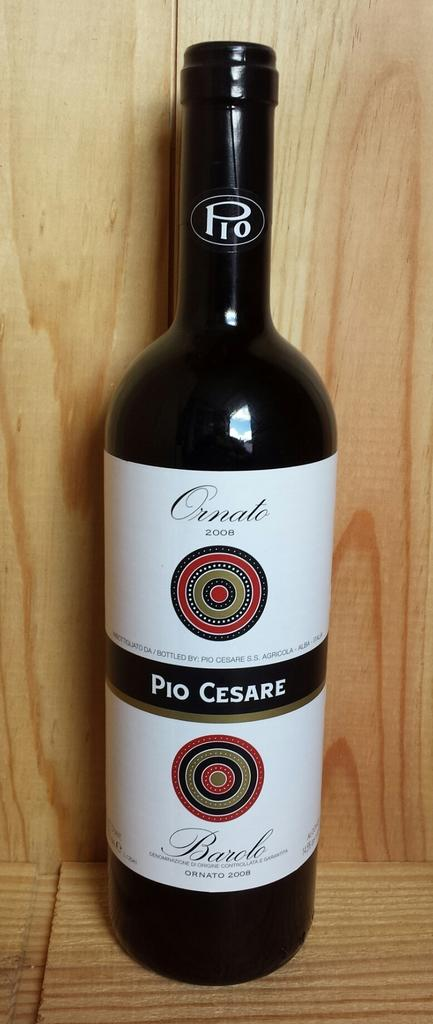<image>
Write a terse but informative summary of the picture. a wine bottle named Pio Cesare with a white label 